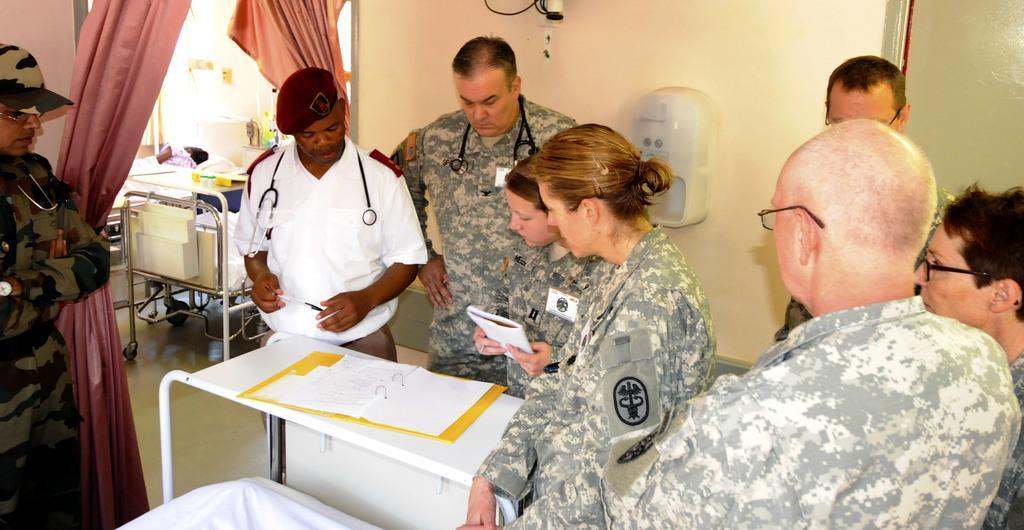In one or two sentences, can you explain what this image depicts? I think this picture is taken in a hospital. There are group of people in a room. 4 people standing besides a table and staring at a file. One person is standing at the left side. 3 persons are standing towards the right side. In the background there is a wall, curtain, table and a bed. 